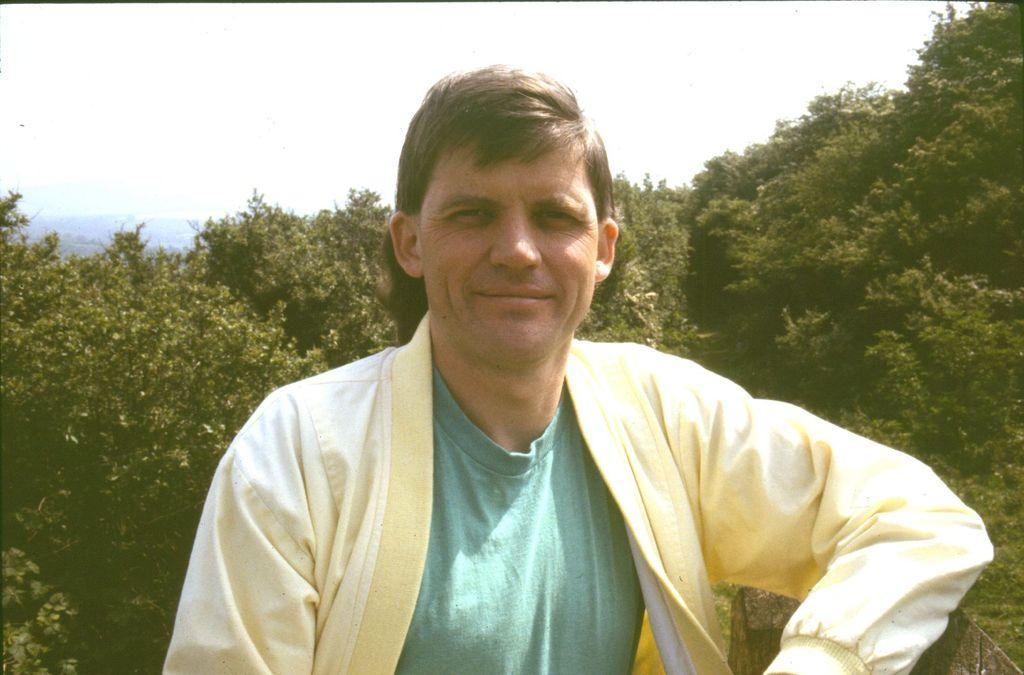What is the main subject of the picture? The main subject of the picture is a man. Can you describe the man's clothing in the picture? The man is wearing a yellow and green shirt. What is the man doing in the picture? The man is posing for a photograph. What can be seen in the background of the picture? There are trees visible behind the man. How many boats are visible in the picture? There are no boats present in the picture; it features a man posing for a photograph with trees in the background. What type of texture can be seen on the man's shirt in the picture? The provided facts do not mention the texture of the man's shirt, so it cannot be determined from the image. 